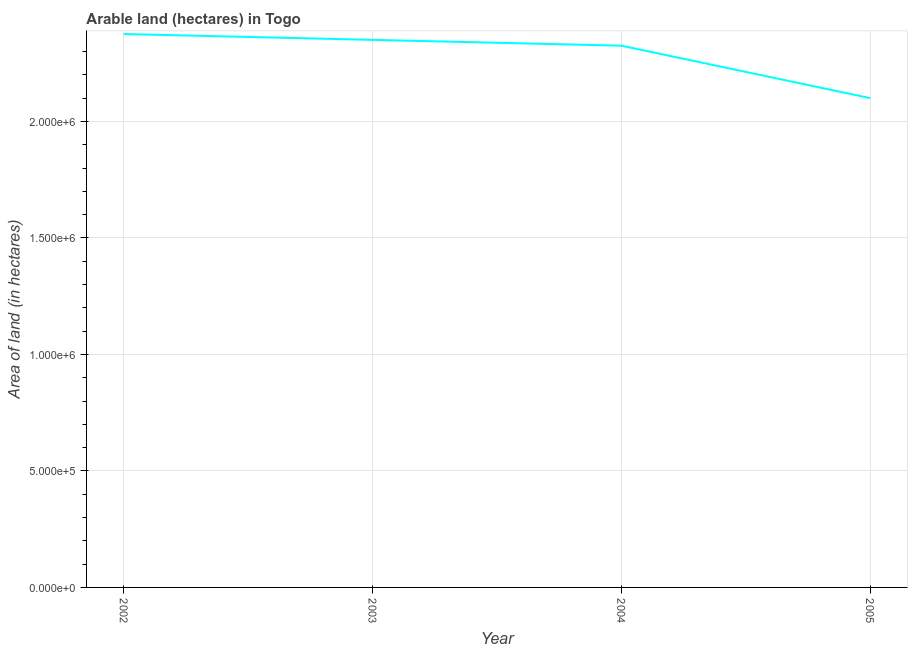What is the area of land in 2004?
Make the answer very short. 2.32e+06. Across all years, what is the maximum area of land?
Make the answer very short. 2.38e+06. Across all years, what is the minimum area of land?
Provide a succinct answer. 2.10e+06. In which year was the area of land maximum?
Your response must be concise. 2002. What is the sum of the area of land?
Provide a succinct answer. 9.15e+06. What is the difference between the area of land in 2002 and 2003?
Keep it short and to the point. 2.50e+04. What is the average area of land per year?
Your answer should be very brief. 2.29e+06. What is the median area of land?
Your answer should be very brief. 2.34e+06. In how many years, is the area of land greater than 1200000 hectares?
Offer a terse response. 4. What is the ratio of the area of land in 2002 to that in 2004?
Provide a short and direct response. 1.02. Is the area of land in 2002 less than that in 2005?
Your response must be concise. No. Is the difference between the area of land in 2002 and 2004 greater than the difference between any two years?
Your response must be concise. No. What is the difference between the highest and the second highest area of land?
Provide a short and direct response. 2.50e+04. Is the sum of the area of land in 2004 and 2005 greater than the maximum area of land across all years?
Offer a terse response. Yes. What is the difference between the highest and the lowest area of land?
Provide a short and direct response. 2.75e+05. Does the area of land monotonically increase over the years?
Your response must be concise. No. How many lines are there?
Keep it short and to the point. 1. Are the values on the major ticks of Y-axis written in scientific E-notation?
Offer a very short reply. Yes. Does the graph contain grids?
Offer a very short reply. Yes. What is the title of the graph?
Keep it short and to the point. Arable land (hectares) in Togo. What is the label or title of the X-axis?
Give a very brief answer. Year. What is the label or title of the Y-axis?
Offer a terse response. Area of land (in hectares). What is the Area of land (in hectares) in 2002?
Give a very brief answer. 2.38e+06. What is the Area of land (in hectares) of 2003?
Provide a succinct answer. 2.35e+06. What is the Area of land (in hectares) of 2004?
Ensure brevity in your answer.  2.32e+06. What is the Area of land (in hectares) in 2005?
Offer a very short reply. 2.10e+06. What is the difference between the Area of land (in hectares) in 2002 and 2003?
Make the answer very short. 2.50e+04. What is the difference between the Area of land (in hectares) in 2002 and 2005?
Keep it short and to the point. 2.75e+05. What is the difference between the Area of land (in hectares) in 2003 and 2004?
Your answer should be compact. 2.50e+04. What is the difference between the Area of land (in hectares) in 2004 and 2005?
Offer a terse response. 2.25e+05. What is the ratio of the Area of land (in hectares) in 2002 to that in 2003?
Your response must be concise. 1.01. What is the ratio of the Area of land (in hectares) in 2002 to that in 2005?
Give a very brief answer. 1.13. What is the ratio of the Area of land (in hectares) in 2003 to that in 2005?
Give a very brief answer. 1.12. What is the ratio of the Area of land (in hectares) in 2004 to that in 2005?
Make the answer very short. 1.11. 